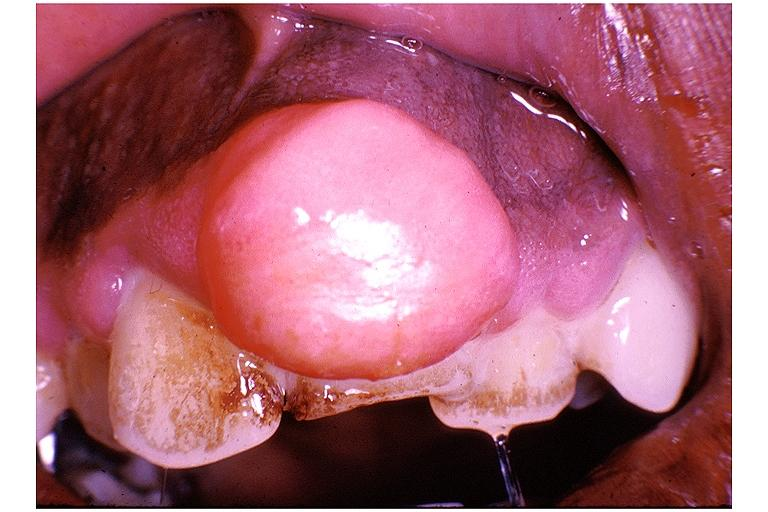does this image show periodontal fibroma?
Answer the question using a single word or phrase. Yes 